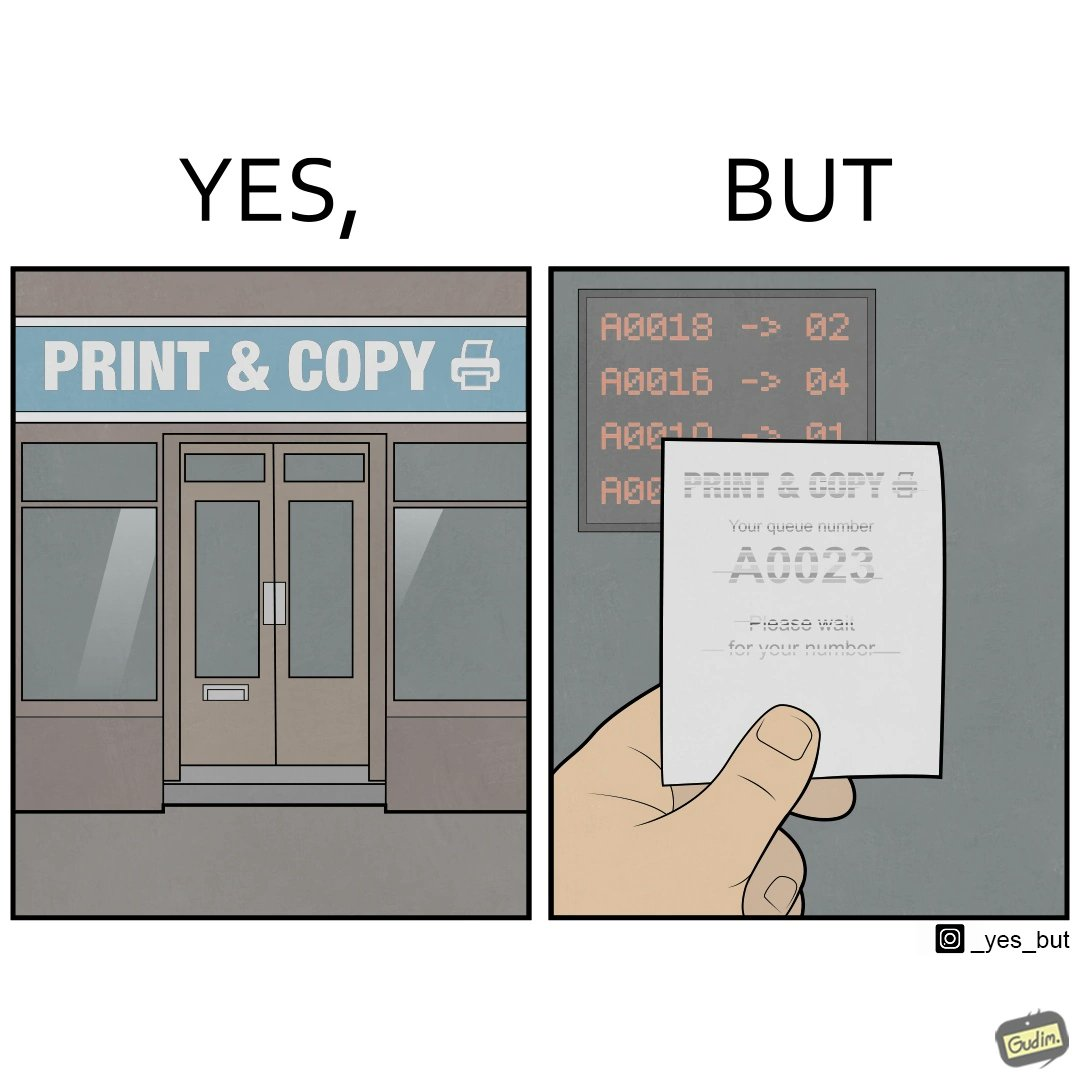What does this image depict? The image is ironic, as the waiting slip in a "Print & Copy" Centre is printed with insufficient printing ink. 